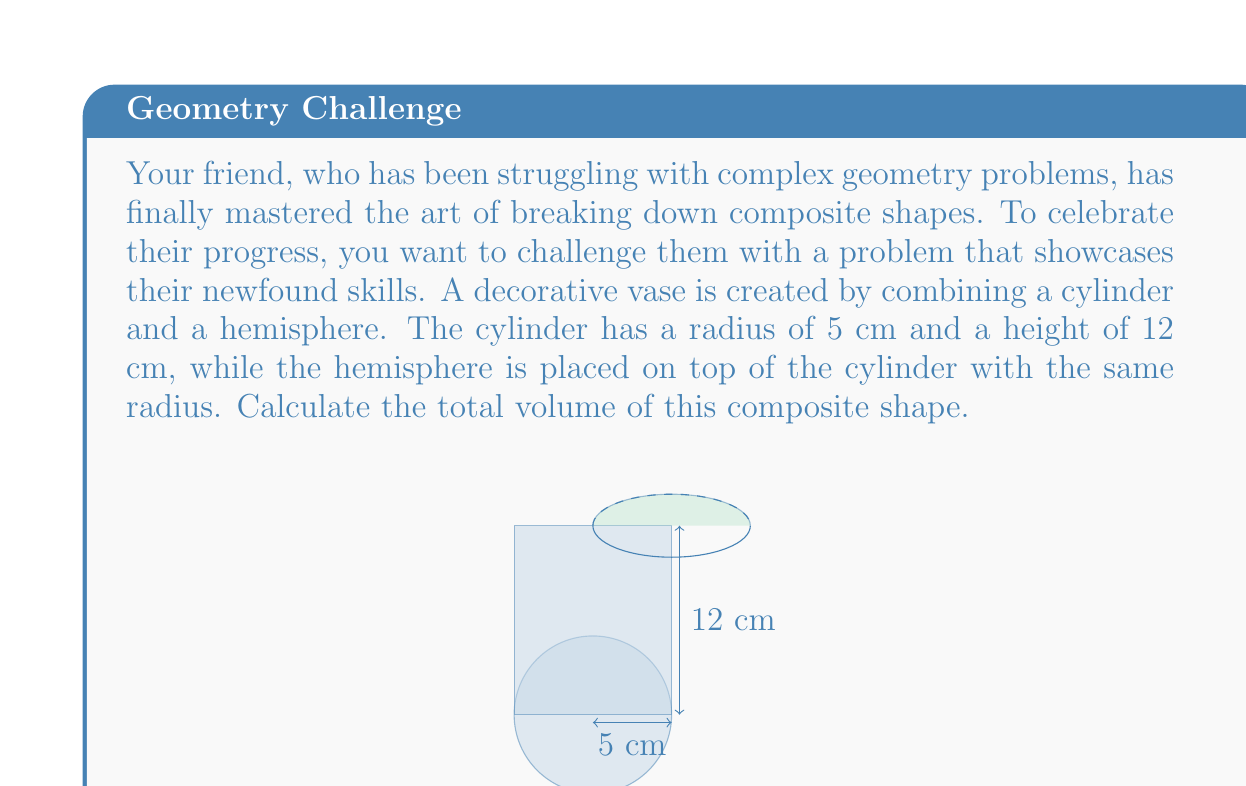Provide a solution to this math problem. To solve this problem, we need to calculate the volumes of the cylinder and hemisphere separately, then add them together. Let's break it down step by step:

1. Volume of the cylinder:
   The formula for the volume of a cylinder is $V_{cylinder} = \pi r^2 h$
   where $r$ is the radius and $h$ is the height.
   
   $V_{cylinder} = \pi \cdot 5^2 \cdot 12 = 300\pi$ cm³

2. Volume of the hemisphere:
   The formula for the volume of a hemisphere is $V_{hemisphere} = \frac{2}{3}\pi r^3$
   where $r$ is the radius.
   
   $V_{hemisphere} = \frac{2}{3}\pi \cdot 5^3 = \frac{250}{3}\pi$ cm³

3. Total volume:
   $V_{total} = V_{cylinder} + V_{hemisphere}$
   $V_{total} = 300\pi + \frac{250}{3}\pi$
   $V_{total} = \frac{900}{3}\pi + \frac{250}{3}\pi$
   $V_{total} = \frac{1150}{3}\pi$ cm³

Therefore, the total volume of the composite shape is $\frac{1150}{3}\pi$ cm³.
Answer: $\frac{1150}{3}\pi$ cm³ or approximately 1204.16 cm³ 